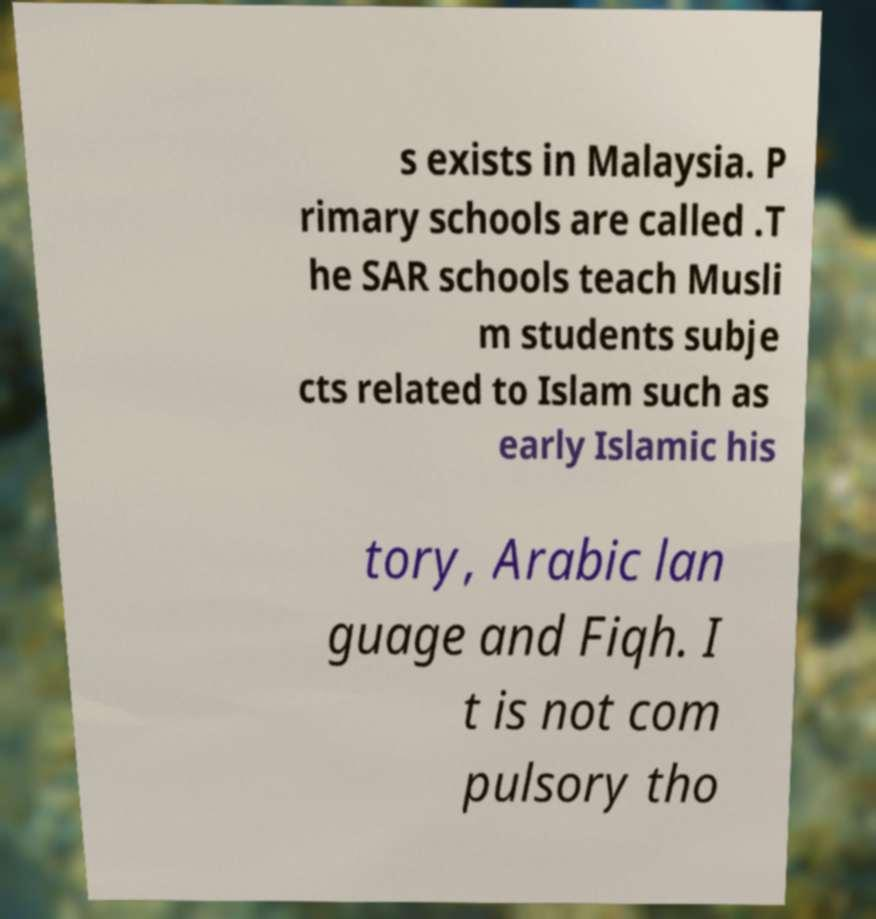I need the written content from this picture converted into text. Can you do that? s exists in Malaysia. P rimary schools are called .T he SAR schools teach Musli m students subje cts related to Islam such as early Islamic his tory, Arabic lan guage and Fiqh. I t is not com pulsory tho 